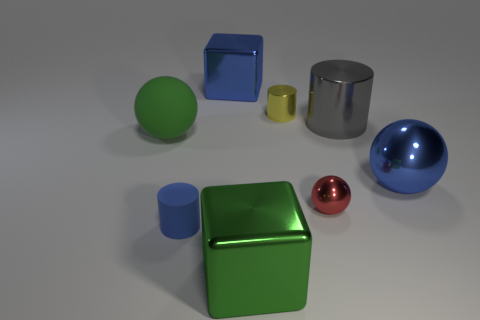Which object in the image is the largest? The largest object in the image appears to be the green cube, judging by its relative dimensions compared to the other objects. 